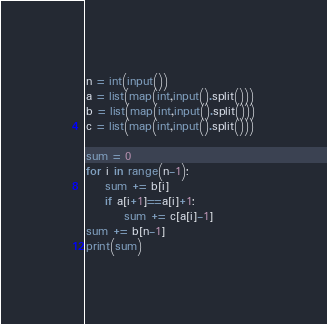<code> <loc_0><loc_0><loc_500><loc_500><_Python_>n = int(input())
a = list(map(int,input().split()))
b = list(map(int,input().split()))
c = list(map(int,input().split()))

sum = 0
for i in range(n-1):
    sum += b[i]
    if a[i+1]==a[i]+1:
        sum += c[a[i]-1]
sum += b[n-1]
print(sum)</code> 